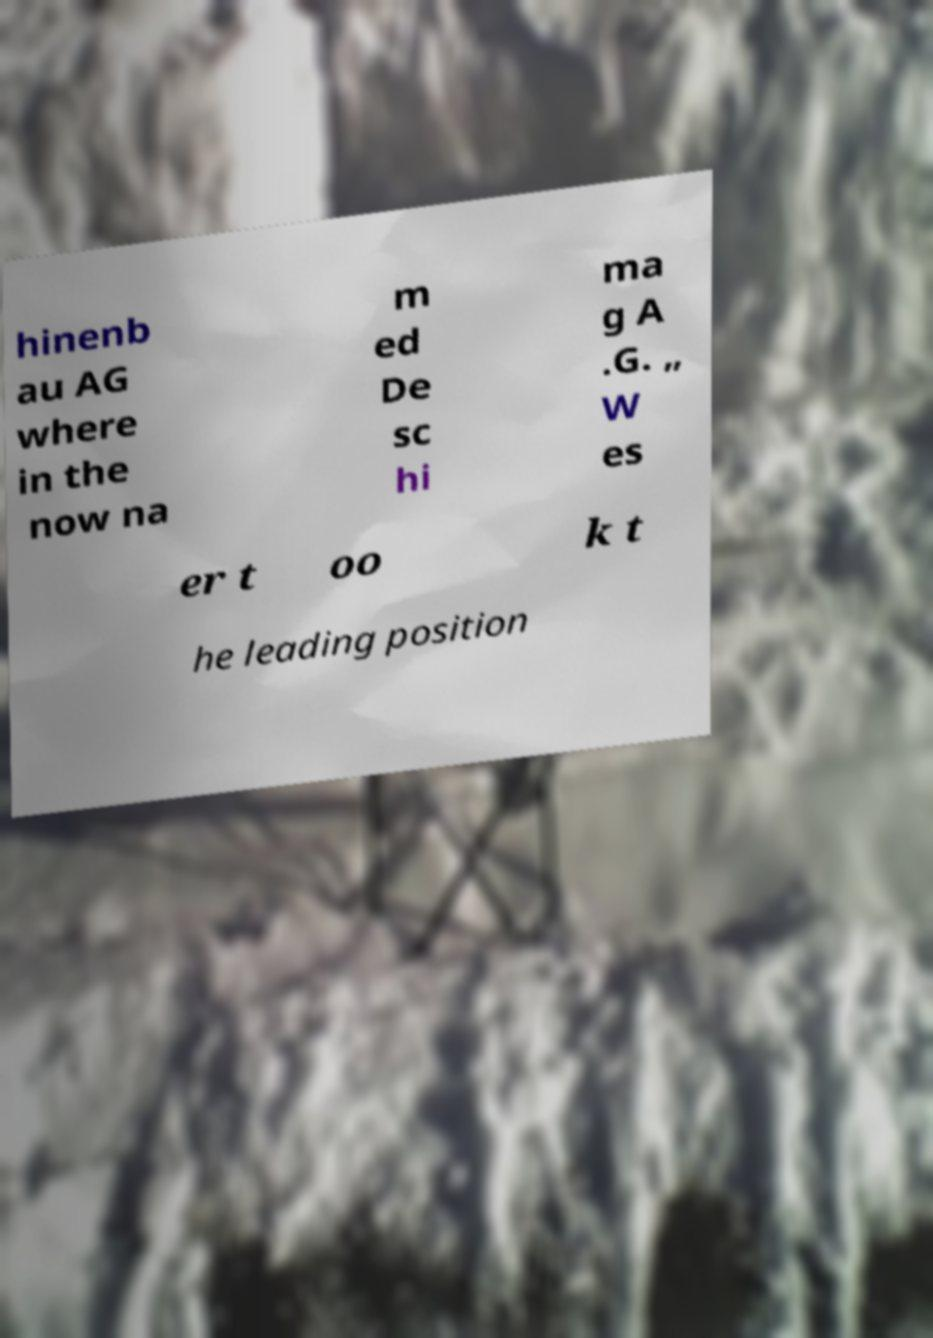For documentation purposes, I need the text within this image transcribed. Could you provide that? hinenb au AG where in the now na m ed De sc hi ma g A .G. „ W es er t oo k t he leading position 